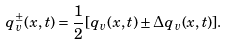Convert formula to latex. <formula><loc_0><loc_0><loc_500><loc_500>q ^ { \pm } _ { v } ( x , t ) = \frac { 1 } { 2 } [ q _ { v } ( x , t ) \pm \Delta q _ { v } ( x , t ) ] .</formula> 